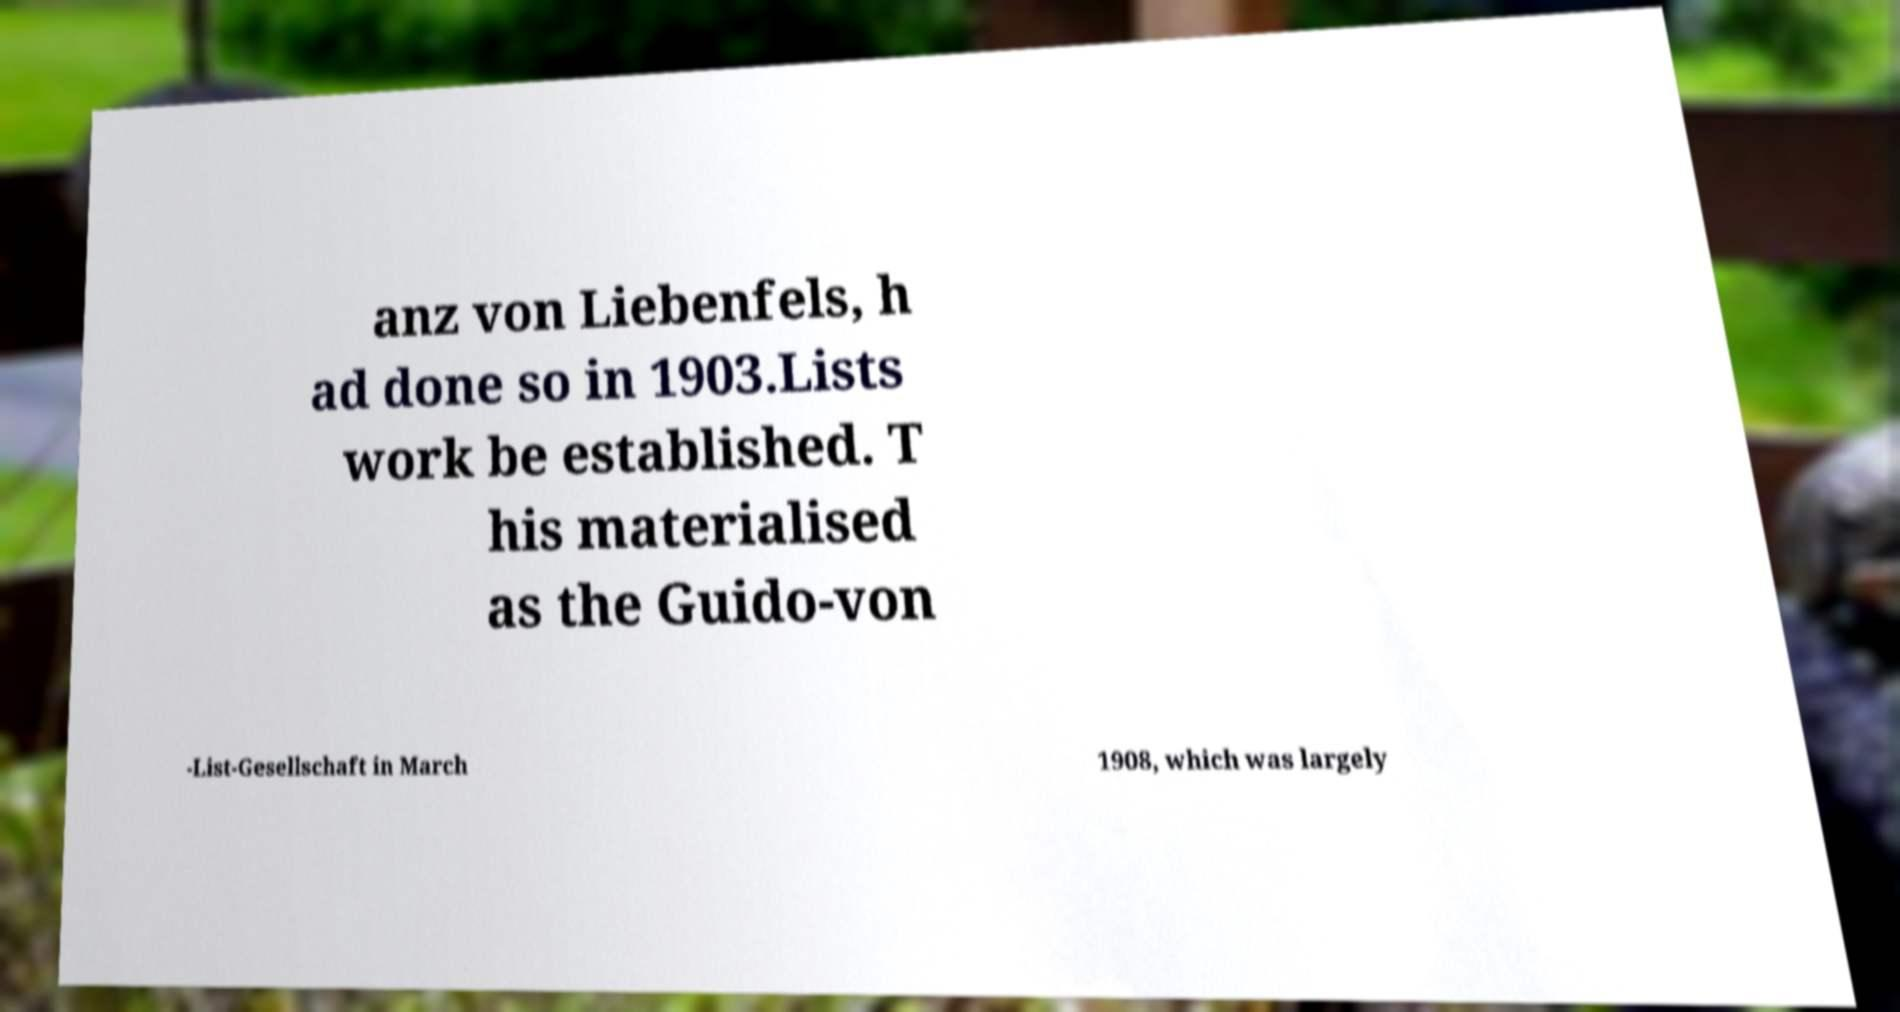Could you assist in decoding the text presented in this image and type it out clearly? anz von Liebenfels, h ad done so in 1903.Lists work be established. T his materialised as the Guido-von -List-Gesellschaft in March 1908, which was largely 